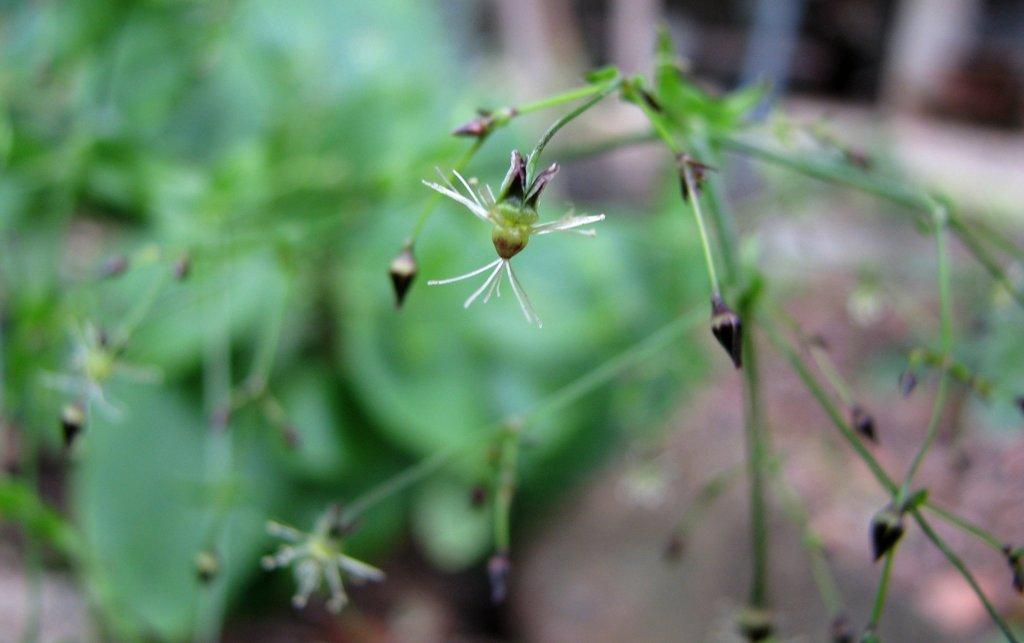What type of objects are present in the image? There are flowers in the image. Can you describe the colors of the flowers? The flowers are in purple and white colors. What can be seen in the background of the image? The background of the image is green. What type of vest is being worn by the zinc in the image? There is no vest, zinc, or any person wearing a vest present in the image. The image only features flowers and a green background. 